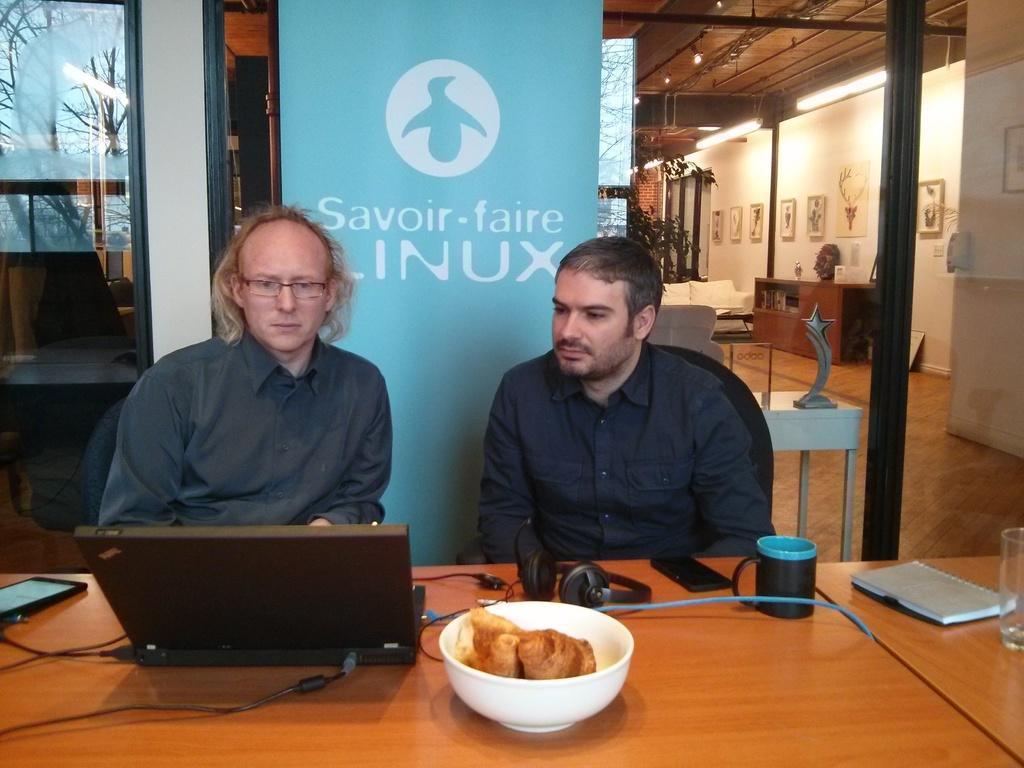Please provide a concise description of this image. There are two persons sitting on the chairs. This is table. On the table there is a laptop, mobile, bowl, and a cup. This is floor and there is a banner. On the background there is wall and these are the frames. This is pole and there are lights. And this is glass. 